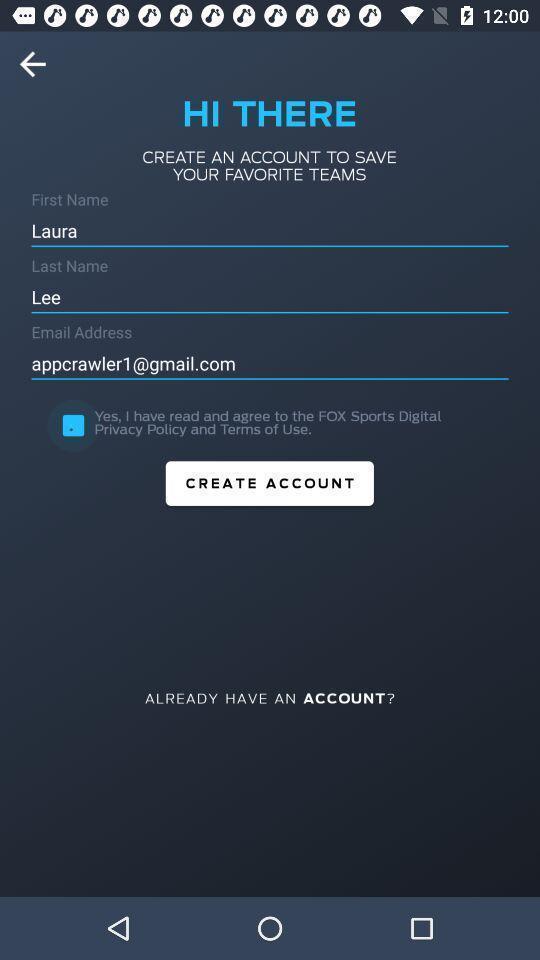What is the overall content of this screenshot? Page displaying to create a account. 